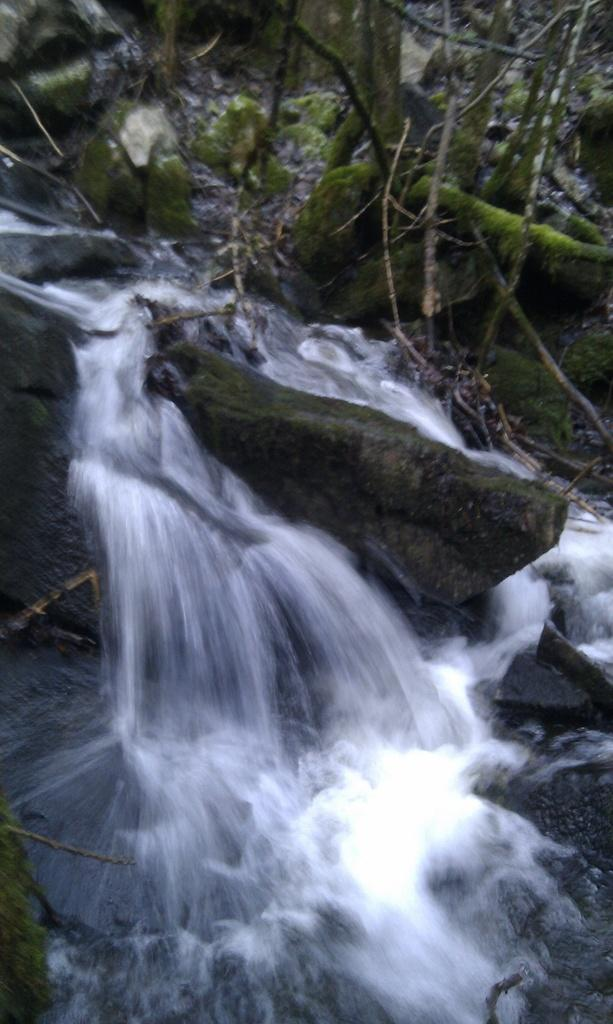What is happening in the image? Water is flowing in the image. What is the water flowing on? The water is flowing on rocks. Where is the clover growing in the image? There is no clover present in the image. What type of chair can be seen in the image? There is no chair present in the image. 